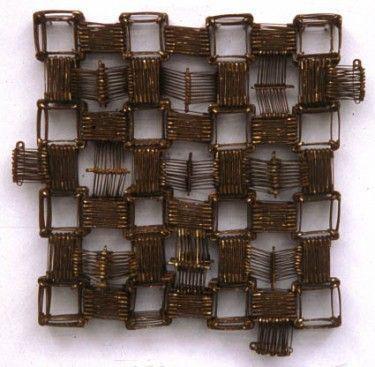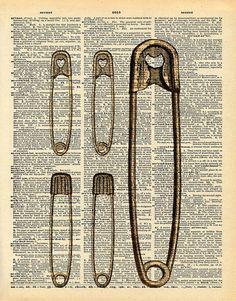The first image is the image on the left, the second image is the image on the right. Considering the images on both sides, is "The left image shows safety pins arranged in a kind of checkerboard pattern, and the right image includes at least one vertical safety pin depiction." valid? Answer yes or no. Yes. 